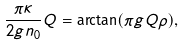Convert formula to latex. <formula><loc_0><loc_0><loc_500><loc_500>\frac { \pi \kappa } { 2 g n _ { 0 } } Q = \arctan ( \pi g Q \rho ) ,</formula> 